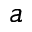<formula> <loc_0><loc_0><loc_500><loc_500>^ { a }</formula> 